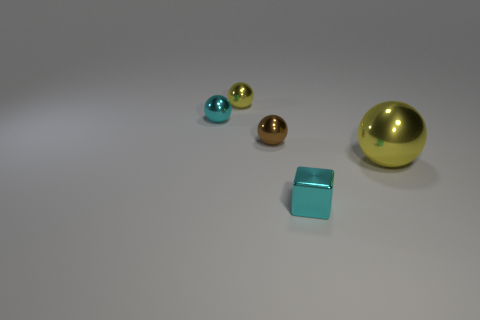Do the tiny object behind the cyan sphere and the large metallic thing have the same color?
Ensure brevity in your answer.  Yes. What number of spheres are in front of the cyan metallic ball and behind the large yellow shiny thing?
Provide a succinct answer. 1. There is another cyan shiny object that is the same shape as the big metallic thing; what is its size?
Give a very brief answer. Small. What number of yellow spheres are behind the tiny ball that is on the right side of the tiny metal object behind the cyan ball?
Offer a very short reply. 1. There is a tiny sphere on the left side of the yellow object behind the brown thing; what is its color?
Ensure brevity in your answer.  Cyan. What number of other objects are there of the same material as the small brown thing?
Offer a very short reply. 4. There is a yellow object to the left of the cyan block; what number of small cyan things are right of it?
Your response must be concise. 1. Are there any other things that are the same shape as the brown object?
Your answer should be compact. Yes. There is a block in front of the big object; is its color the same as the sphere right of the cyan metallic block?
Your answer should be compact. No. Is the number of small yellow rubber things less than the number of small spheres?
Provide a succinct answer. Yes. 